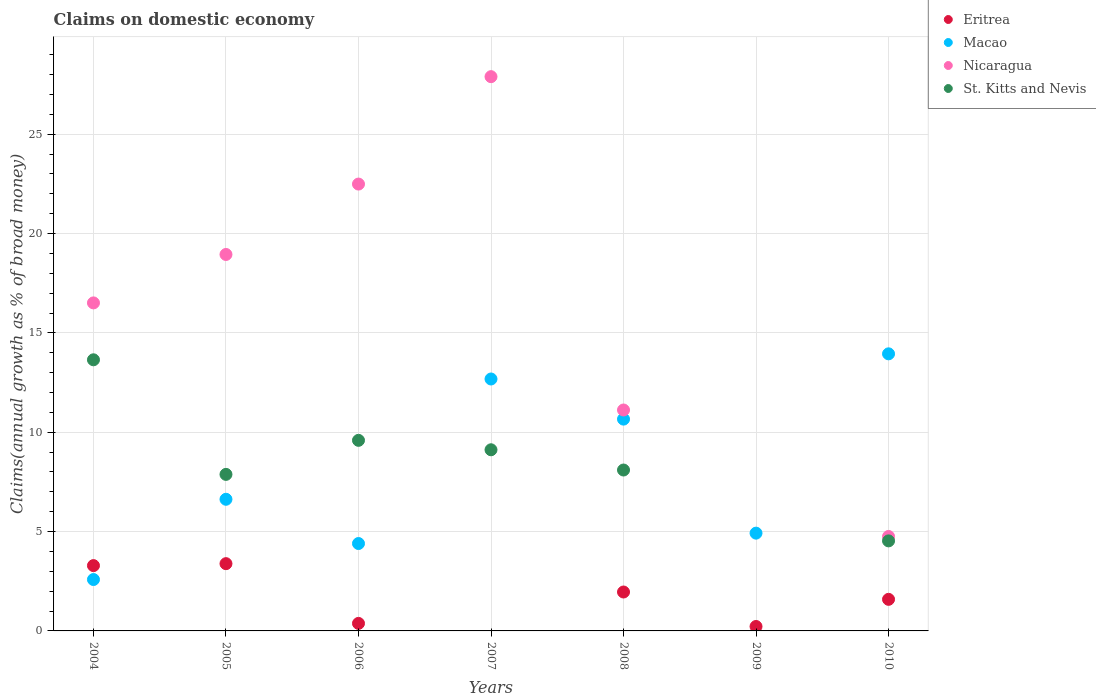How many different coloured dotlines are there?
Your response must be concise. 4. What is the percentage of broad money claimed on domestic economy in Eritrea in 2010?
Keep it short and to the point. 1.59. Across all years, what is the maximum percentage of broad money claimed on domestic economy in Nicaragua?
Give a very brief answer. 27.9. Across all years, what is the minimum percentage of broad money claimed on domestic economy in Macao?
Offer a terse response. 2.59. In which year was the percentage of broad money claimed on domestic economy in St. Kitts and Nevis maximum?
Your response must be concise. 2004. What is the total percentage of broad money claimed on domestic economy in Macao in the graph?
Provide a short and direct response. 55.82. What is the difference between the percentage of broad money claimed on domestic economy in St. Kitts and Nevis in 2004 and that in 2006?
Offer a terse response. 4.05. What is the difference between the percentage of broad money claimed on domestic economy in Nicaragua in 2009 and the percentage of broad money claimed on domestic economy in Macao in 2007?
Your answer should be compact. -12.68. What is the average percentage of broad money claimed on domestic economy in Nicaragua per year?
Provide a short and direct response. 14.53. In the year 2007, what is the difference between the percentage of broad money claimed on domestic economy in St. Kitts and Nevis and percentage of broad money claimed on domestic economy in Nicaragua?
Offer a very short reply. -18.78. What is the ratio of the percentage of broad money claimed on domestic economy in Nicaragua in 2006 to that in 2008?
Your answer should be very brief. 2.02. Is the percentage of broad money claimed on domestic economy in Nicaragua in 2005 less than that in 2008?
Provide a short and direct response. No. What is the difference between the highest and the second highest percentage of broad money claimed on domestic economy in Macao?
Offer a terse response. 1.27. What is the difference between the highest and the lowest percentage of broad money claimed on domestic economy in St. Kitts and Nevis?
Provide a succinct answer. 13.65. In how many years, is the percentage of broad money claimed on domestic economy in Nicaragua greater than the average percentage of broad money claimed on domestic economy in Nicaragua taken over all years?
Your answer should be very brief. 4. Is it the case that in every year, the sum of the percentage of broad money claimed on domestic economy in Eritrea and percentage of broad money claimed on domestic economy in Macao  is greater than the percentage of broad money claimed on domestic economy in St. Kitts and Nevis?
Provide a short and direct response. No. Is the percentage of broad money claimed on domestic economy in Nicaragua strictly greater than the percentage of broad money claimed on domestic economy in St. Kitts and Nevis over the years?
Provide a short and direct response. Yes. Is the percentage of broad money claimed on domestic economy in St. Kitts and Nevis strictly less than the percentage of broad money claimed on domestic economy in Macao over the years?
Provide a succinct answer. No. Are the values on the major ticks of Y-axis written in scientific E-notation?
Offer a very short reply. No. Does the graph contain any zero values?
Provide a short and direct response. Yes. Does the graph contain grids?
Make the answer very short. Yes. Where does the legend appear in the graph?
Ensure brevity in your answer.  Top right. What is the title of the graph?
Keep it short and to the point. Claims on domestic economy. What is the label or title of the Y-axis?
Provide a succinct answer. Claims(annual growth as % of broad money). What is the Claims(annual growth as % of broad money) in Eritrea in 2004?
Ensure brevity in your answer.  3.29. What is the Claims(annual growth as % of broad money) of Macao in 2004?
Your answer should be compact. 2.59. What is the Claims(annual growth as % of broad money) of Nicaragua in 2004?
Ensure brevity in your answer.  16.51. What is the Claims(annual growth as % of broad money) of St. Kitts and Nevis in 2004?
Keep it short and to the point. 13.65. What is the Claims(annual growth as % of broad money) of Eritrea in 2005?
Ensure brevity in your answer.  3.39. What is the Claims(annual growth as % of broad money) of Macao in 2005?
Your answer should be compact. 6.63. What is the Claims(annual growth as % of broad money) in Nicaragua in 2005?
Provide a short and direct response. 18.95. What is the Claims(annual growth as % of broad money) in St. Kitts and Nevis in 2005?
Keep it short and to the point. 7.88. What is the Claims(annual growth as % of broad money) in Eritrea in 2006?
Offer a terse response. 0.38. What is the Claims(annual growth as % of broad money) in Macao in 2006?
Provide a succinct answer. 4.4. What is the Claims(annual growth as % of broad money) in Nicaragua in 2006?
Offer a terse response. 22.49. What is the Claims(annual growth as % of broad money) in St. Kitts and Nevis in 2006?
Provide a short and direct response. 9.59. What is the Claims(annual growth as % of broad money) in Macao in 2007?
Your answer should be compact. 12.68. What is the Claims(annual growth as % of broad money) in Nicaragua in 2007?
Make the answer very short. 27.9. What is the Claims(annual growth as % of broad money) in St. Kitts and Nevis in 2007?
Offer a very short reply. 9.12. What is the Claims(annual growth as % of broad money) of Eritrea in 2008?
Offer a terse response. 1.96. What is the Claims(annual growth as % of broad money) of Macao in 2008?
Give a very brief answer. 10.66. What is the Claims(annual growth as % of broad money) in Nicaragua in 2008?
Your answer should be very brief. 11.12. What is the Claims(annual growth as % of broad money) in St. Kitts and Nevis in 2008?
Offer a very short reply. 8.1. What is the Claims(annual growth as % of broad money) of Eritrea in 2009?
Offer a very short reply. 0.22. What is the Claims(annual growth as % of broad money) of Macao in 2009?
Your answer should be very brief. 4.92. What is the Claims(annual growth as % of broad money) of Nicaragua in 2009?
Offer a terse response. 0. What is the Claims(annual growth as % of broad money) of Eritrea in 2010?
Keep it short and to the point. 1.59. What is the Claims(annual growth as % of broad money) in Macao in 2010?
Offer a very short reply. 13.95. What is the Claims(annual growth as % of broad money) of Nicaragua in 2010?
Provide a short and direct response. 4.75. What is the Claims(annual growth as % of broad money) of St. Kitts and Nevis in 2010?
Make the answer very short. 4.53. Across all years, what is the maximum Claims(annual growth as % of broad money) in Eritrea?
Keep it short and to the point. 3.39. Across all years, what is the maximum Claims(annual growth as % of broad money) of Macao?
Your answer should be very brief. 13.95. Across all years, what is the maximum Claims(annual growth as % of broad money) of Nicaragua?
Offer a terse response. 27.9. Across all years, what is the maximum Claims(annual growth as % of broad money) of St. Kitts and Nevis?
Your answer should be compact. 13.65. Across all years, what is the minimum Claims(annual growth as % of broad money) in Eritrea?
Your answer should be very brief. 0. Across all years, what is the minimum Claims(annual growth as % of broad money) in Macao?
Make the answer very short. 2.59. Across all years, what is the minimum Claims(annual growth as % of broad money) of Nicaragua?
Make the answer very short. 0. What is the total Claims(annual growth as % of broad money) in Eritrea in the graph?
Provide a succinct answer. 10.82. What is the total Claims(annual growth as % of broad money) of Macao in the graph?
Keep it short and to the point. 55.82. What is the total Claims(annual growth as % of broad money) in Nicaragua in the graph?
Your answer should be compact. 101.71. What is the total Claims(annual growth as % of broad money) of St. Kitts and Nevis in the graph?
Keep it short and to the point. 52.86. What is the difference between the Claims(annual growth as % of broad money) in Eritrea in 2004 and that in 2005?
Offer a terse response. -0.1. What is the difference between the Claims(annual growth as % of broad money) of Macao in 2004 and that in 2005?
Make the answer very short. -4.04. What is the difference between the Claims(annual growth as % of broad money) in Nicaragua in 2004 and that in 2005?
Provide a short and direct response. -2.44. What is the difference between the Claims(annual growth as % of broad money) in St. Kitts and Nevis in 2004 and that in 2005?
Offer a very short reply. 5.77. What is the difference between the Claims(annual growth as % of broad money) of Eritrea in 2004 and that in 2006?
Make the answer very short. 2.91. What is the difference between the Claims(annual growth as % of broad money) of Macao in 2004 and that in 2006?
Provide a short and direct response. -1.81. What is the difference between the Claims(annual growth as % of broad money) of Nicaragua in 2004 and that in 2006?
Provide a succinct answer. -5.98. What is the difference between the Claims(annual growth as % of broad money) in St. Kitts and Nevis in 2004 and that in 2006?
Your answer should be very brief. 4.05. What is the difference between the Claims(annual growth as % of broad money) in Macao in 2004 and that in 2007?
Your response must be concise. -10.09. What is the difference between the Claims(annual growth as % of broad money) of Nicaragua in 2004 and that in 2007?
Give a very brief answer. -11.39. What is the difference between the Claims(annual growth as % of broad money) in St. Kitts and Nevis in 2004 and that in 2007?
Your response must be concise. 4.53. What is the difference between the Claims(annual growth as % of broad money) of Eritrea in 2004 and that in 2008?
Provide a succinct answer. 1.33. What is the difference between the Claims(annual growth as % of broad money) of Macao in 2004 and that in 2008?
Provide a succinct answer. -8.07. What is the difference between the Claims(annual growth as % of broad money) of Nicaragua in 2004 and that in 2008?
Provide a short and direct response. 5.39. What is the difference between the Claims(annual growth as % of broad money) of St. Kitts and Nevis in 2004 and that in 2008?
Ensure brevity in your answer.  5.55. What is the difference between the Claims(annual growth as % of broad money) of Eritrea in 2004 and that in 2009?
Provide a succinct answer. 3.06. What is the difference between the Claims(annual growth as % of broad money) in Macao in 2004 and that in 2009?
Your response must be concise. -2.33. What is the difference between the Claims(annual growth as % of broad money) of Eritrea in 2004 and that in 2010?
Offer a terse response. 1.7. What is the difference between the Claims(annual growth as % of broad money) of Macao in 2004 and that in 2010?
Offer a very short reply. -11.36. What is the difference between the Claims(annual growth as % of broad money) in Nicaragua in 2004 and that in 2010?
Provide a short and direct response. 11.76. What is the difference between the Claims(annual growth as % of broad money) of St. Kitts and Nevis in 2004 and that in 2010?
Provide a short and direct response. 9.11. What is the difference between the Claims(annual growth as % of broad money) in Eritrea in 2005 and that in 2006?
Make the answer very short. 3.01. What is the difference between the Claims(annual growth as % of broad money) of Macao in 2005 and that in 2006?
Your response must be concise. 2.23. What is the difference between the Claims(annual growth as % of broad money) of Nicaragua in 2005 and that in 2006?
Provide a succinct answer. -3.54. What is the difference between the Claims(annual growth as % of broad money) of St. Kitts and Nevis in 2005 and that in 2006?
Ensure brevity in your answer.  -1.71. What is the difference between the Claims(annual growth as % of broad money) of Macao in 2005 and that in 2007?
Offer a very short reply. -6.05. What is the difference between the Claims(annual growth as % of broad money) of Nicaragua in 2005 and that in 2007?
Offer a very short reply. -8.95. What is the difference between the Claims(annual growth as % of broad money) in St. Kitts and Nevis in 2005 and that in 2007?
Your response must be concise. -1.24. What is the difference between the Claims(annual growth as % of broad money) in Eritrea in 2005 and that in 2008?
Give a very brief answer. 1.43. What is the difference between the Claims(annual growth as % of broad money) in Macao in 2005 and that in 2008?
Your answer should be compact. -4.03. What is the difference between the Claims(annual growth as % of broad money) of Nicaragua in 2005 and that in 2008?
Provide a short and direct response. 7.83. What is the difference between the Claims(annual growth as % of broad money) in St. Kitts and Nevis in 2005 and that in 2008?
Ensure brevity in your answer.  -0.22. What is the difference between the Claims(annual growth as % of broad money) in Eritrea in 2005 and that in 2009?
Offer a terse response. 3.16. What is the difference between the Claims(annual growth as % of broad money) in Macao in 2005 and that in 2009?
Offer a terse response. 1.7. What is the difference between the Claims(annual growth as % of broad money) in Eritrea in 2005 and that in 2010?
Your answer should be compact. 1.8. What is the difference between the Claims(annual growth as % of broad money) in Macao in 2005 and that in 2010?
Offer a terse response. -7.32. What is the difference between the Claims(annual growth as % of broad money) in Nicaragua in 2005 and that in 2010?
Provide a short and direct response. 14.19. What is the difference between the Claims(annual growth as % of broad money) of St. Kitts and Nevis in 2005 and that in 2010?
Offer a very short reply. 3.35. What is the difference between the Claims(annual growth as % of broad money) in Macao in 2006 and that in 2007?
Provide a succinct answer. -8.28. What is the difference between the Claims(annual growth as % of broad money) in Nicaragua in 2006 and that in 2007?
Offer a very short reply. -5.41. What is the difference between the Claims(annual growth as % of broad money) of St. Kitts and Nevis in 2006 and that in 2007?
Make the answer very short. 0.47. What is the difference between the Claims(annual growth as % of broad money) of Eritrea in 2006 and that in 2008?
Your answer should be very brief. -1.58. What is the difference between the Claims(annual growth as % of broad money) of Macao in 2006 and that in 2008?
Offer a terse response. -6.26. What is the difference between the Claims(annual growth as % of broad money) of Nicaragua in 2006 and that in 2008?
Keep it short and to the point. 11.37. What is the difference between the Claims(annual growth as % of broad money) in St. Kitts and Nevis in 2006 and that in 2008?
Ensure brevity in your answer.  1.49. What is the difference between the Claims(annual growth as % of broad money) in Eritrea in 2006 and that in 2009?
Give a very brief answer. 0.16. What is the difference between the Claims(annual growth as % of broad money) of Macao in 2006 and that in 2009?
Your answer should be very brief. -0.52. What is the difference between the Claims(annual growth as % of broad money) in Eritrea in 2006 and that in 2010?
Offer a terse response. -1.21. What is the difference between the Claims(annual growth as % of broad money) in Macao in 2006 and that in 2010?
Provide a short and direct response. -9.55. What is the difference between the Claims(annual growth as % of broad money) in Nicaragua in 2006 and that in 2010?
Offer a terse response. 17.74. What is the difference between the Claims(annual growth as % of broad money) of St. Kitts and Nevis in 2006 and that in 2010?
Keep it short and to the point. 5.06. What is the difference between the Claims(annual growth as % of broad money) of Macao in 2007 and that in 2008?
Give a very brief answer. 2.02. What is the difference between the Claims(annual growth as % of broad money) in Nicaragua in 2007 and that in 2008?
Your response must be concise. 16.78. What is the difference between the Claims(annual growth as % of broad money) of St. Kitts and Nevis in 2007 and that in 2008?
Provide a short and direct response. 1.02. What is the difference between the Claims(annual growth as % of broad money) of Macao in 2007 and that in 2009?
Give a very brief answer. 7.76. What is the difference between the Claims(annual growth as % of broad money) of Macao in 2007 and that in 2010?
Provide a succinct answer. -1.27. What is the difference between the Claims(annual growth as % of broad money) in Nicaragua in 2007 and that in 2010?
Offer a terse response. 23.14. What is the difference between the Claims(annual growth as % of broad money) in St. Kitts and Nevis in 2007 and that in 2010?
Offer a very short reply. 4.59. What is the difference between the Claims(annual growth as % of broad money) in Eritrea in 2008 and that in 2009?
Offer a very short reply. 1.74. What is the difference between the Claims(annual growth as % of broad money) of Macao in 2008 and that in 2009?
Make the answer very short. 5.74. What is the difference between the Claims(annual growth as % of broad money) in Eritrea in 2008 and that in 2010?
Provide a short and direct response. 0.37. What is the difference between the Claims(annual growth as % of broad money) in Macao in 2008 and that in 2010?
Offer a very short reply. -3.29. What is the difference between the Claims(annual growth as % of broad money) of Nicaragua in 2008 and that in 2010?
Your answer should be very brief. 6.37. What is the difference between the Claims(annual growth as % of broad money) of St. Kitts and Nevis in 2008 and that in 2010?
Your answer should be compact. 3.57. What is the difference between the Claims(annual growth as % of broad money) of Eritrea in 2009 and that in 2010?
Your answer should be compact. -1.37. What is the difference between the Claims(annual growth as % of broad money) in Macao in 2009 and that in 2010?
Ensure brevity in your answer.  -9.02. What is the difference between the Claims(annual growth as % of broad money) of Eritrea in 2004 and the Claims(annual growth as % of broad money) of Macao in 2005?
Provide a short and direct response. -3.34. What is the difference between the Claims(annual growth as % of broad money) of Eritrea in 2004 and the Claims(annual growth as % of broad money) of Nicaragua in 2005?
Offer a very short reply. -15.66. What is the difference between the Claims(annual growth as % of broad money) of Eritrea in 2004 and the Claims(annual growth as % of broad money) of St. Kitts and Nevis in 2005?
Your answer should be compact. -4.59. What is the difference between the Claims(annual growth as % of broad money) in Macao in 2004 and the Claims(annual growth as % of broad money) in Nicaragua in 2005?
Your response must be concise. -16.36. What is the difference between the Claims(annual growth as % of broad money) of Macao in 2004 and the Claims(annual growth as % of broad money) of St. Kitts and Nevis in 2005?
Your response must be concise. -5.29. What is the difference between the Claims(annual growth as % of broad money) of Nicaragua in 2004 and the Claims(annual growth as % of broad money) of St. Kitts and Nevis in 2005?
Offer a terse response. 8.63. What is the difference between the Claims(annual growth as % of broad money) of Eritrea in 2004 and the Claims(annual growth as % of broad money) of Macao in 2006?
Keep it short and to the point. -1.11. What is the difference between the Claims(annual growth as % of broad money) in Eritrea in 2004 and the Claims(annual growth as % of broad money) in Nicaragua in 2006?
Your answer should be very brief. -19.2. What is the difference between the Claims(annual growth as % of broad money) in Eritrea in 2004 and the Claims(annual growth as % of broad money) in St. Kitts and Nevis in 2006?
Your answer should be compact. -6.3. What is the difference between the Claims(annual growth as % of broad money) of Macao in 2004 and the Claims(annual growth as % of broad money) of Nicaragua in 2006?
Keep it short and to the point. -19.9. What is the difference between the Claims(annual growth as % of broad money) of Macao in 2004 and the Claims(annual growth as % of broad money) of St. Kitts and Nevis in 2006?
Make the answer very short. -7.01. What is the difference between the Claims(annual growth as % of broad money) in Nicaragua in 2004 and the Claims(annual growth as % of broad money) in St. Kitts and Nevis in 2006?
Offer a very short reply. 6.92. What is the difference between the Claims(annual growth as % of broad money) in Eritrea in 2004 and the Claims(annual growth as % of broad money) in Macao in 2007?
Provide a succinct answer. -9.39. What is the difference between the Claims(annual growth as % of broad money) in Eritrea in 2004 and the Claims(annual growth as % of broad money) in Nicaragua in 2007?
Provide a succinct answer. -24.61. What is the difference between the Claims(annual growth as % of broad money) in Eritrea in 2004 and the Claims(annual growth as % of broad money) in St. Kitts and Nevis in 2007?
Offer a terse response. -5.83. What is the difference between the Claims(annual growth as % of broad money) of Macao in 2004 and the Claims(annual growth as % of broad money) of Nicaragua in 2007?
Make the answer very short. -25.31. What is the difference between the Claims(annual growth as % of broad money) in Macao in 2004 and the Claims(annual growth as % of broad money) in St. Kitts and Nevis in 2007?
Offer a terse response. -6.53. What is the difference between the Claims(annual growth as % of broad money) of Nicaragua in 2004 and the Claims(annual growth as % of broad money) of St. Kitts and Nevis in 2007?
Provide a short and direct response. 7.39. What is the difference between the Claims(annual growth as % of broad money) of Eritrea in 2004 and the Claims(annual growth as % of broad money) of Macao in 2008?
Keep it short and to the point. -7.37. What is the difference between the Claims(annual growth as % of broad money) of Eritrea in 2004 and the Claims(annual growth as % of broad money) of Nicaragua in 2008?
Give a very brief answer. -7.83. What is the difference between the Claims(annual growth as % of broad money) of Eritrea in 2004 and the Claims(annual growth as % of broad money) of St. Kitts and Nevis in 2008?
Offer a terse response. -4.81. What is the difference between the Claims(annual growth as % of broad money) in Macao in 2004 and the Claims(annual growth as % of broad money) in Nicaragua in 2008?
Make the answer very short. -8.53. What is the difference between the Claims(annual growth as % of broad money) in Macao in 2004 and the Claims(annual growth as % of broad money) in St. Kitts and Nevis in 2008?
Provide a succinct answer. -5.51. What is the difference between the Claims(annual growth as % of broad money) of Nicaragua in 2004 and the Claims(annual growth as % of broad money) of St. Kitts and Nevis in 2008?
Make the answer very short. 8.41. What is the difference between the Claims(annual growth as % of broad money) of Eritrea in 2004 and the Claims(annual growth as % of broad money) of Macao in 2009?
Make the answer very short. -1.63. What is the difference between the Claims(annual growth as % of broad money) in Eritrea in 2004 and the Claims(annual growth as % of broad money) in Macao in 2010?
Your answer should be very brief. -10.66. What is the difference between the Claims(annual growth as % of broad money) in Eritrea in 2004 and the Claims(annual growth as % of broad money) in Nicaragua in 2010?
Provide a short and direct response. -1.47. What is the difference between the Claims(annual growth as % of broad money) of Eritrea in 2004 and the Claims(annual growth as % of broad money) of St. Kitts and Nevis in 2010?
Your response must be concise. -1.24. What is the difference between the Claims(annual growth as % of broad money) in Macao in 2004 and the Claims(annual growth as % of broad money) in Nicaragua in 2010?
Offer a terse response. -2.17. What is the difference between the Claims(annual growth as % of broad money) of Macao in 2004 and the Claims(annual growth as % of broad money) of St. Kitts and Nevis in 2010?
Keep it short and to the point. -1.95. What is the difference between the Claims(annual growth as % of broad money) in Nicaragua in 2004 and the Claims(annual growth as % of broad money) in St. Kitts and Nevis in 2010?
Ensure brevity in your answer.  11.98. What is the difference between the Claims(annual growth as % of broad money) of Eritrea in 2005 and the Claims(annual growth as % of broad money) of Macao in 2006?
Offer a very short reply. -1.01. What is the difference between the Claims(annual growth as % of broad money) of Eritrea in 2005 and the Claims(annual growth as % of broad money) of Nicaragua in 2006?
Offer a very short reply. -19.1. What is the difference between the Claims(annual growth as % of broad money) of Eritrea in 2005 and the Claims(annual growth as % of broad money) of St. Kitts and Nevis in 2006?
Provide a short and direct response. -6.21. What is the difference between the Claims(annual growth as % of broad money) in Macao in 2005 and the Claims(annual growth as % of broad money) in Nicaragua in 2006?
Offer a very short reply. -15.86. What is the difference between the Claims(annual growth as % of broad money) of Macao in 2005 and the Claims(annual growth as % of broad money) of St. Kitts and Nevis in 2006?
Your response must be concise. -2.97. What is the difference between the Claims(annual growth as % of broad money) in Nicaragua in 2005 and the Claims(annual growth as % of broad money) in St. Kitts and Nevis in 2006?
Offer a very short reply. 9.35. What is the difference between the Claims(annual growth as % of broad money) in Eritrea in 2005 and the Claims(annual growth as % of broad money) in Macao in 2007?
Your answer should be very brief. -9.29. What is the difference between the Claims(annual growth as % of broad money) of Eritrea in 2005 and the Claims(annual growth as % of broad money) of Nicaragua in 2007?
Your answer should be compact. -24.51. What is the difference between the Claims(annual growth as % of broad money) of Eritrea in 2005 and the Claims(annual growth as % of broad money) of St. Kitts and Nevis in 2007?
Offer a terse response. -5.73. What is the difference between the Claims(annual growth as % of broad money) in Macao in 2005 and the Claims(annual growth as % of broad money) in Nicaragua in 2007?
Your answer should be compact. -21.27. What is the difference between the Claims(annual growth as % of broad money) of Macao in 2005 and the Claims(annual growth as % of broad money) of St. Kitts and Nevis in 2007?
Your answer should be compact. -2.49. What is the difference between the Claims(annual growth as % of broad money) of Nicaragua in 2005 and the Claims(annual growth as % of broad money) of St. Kitts and Nevis in 2007?
Give a very brief answer. 9.83. What is the difference between the Claims(annual growth as % of broad money) in Eritrea in 2005 and the Claims(annual growth as % of broad money) in Macao in 2008?
Your answer should be compact. -7.27. What is the difference between the Claims(annual growth as % of broad money) in Eritrea in 2005 and the Claims(annual growth as % of broad money) in Nicaragua in 2008?
Keep it short and to the point. -7.73. What is the difference between the Claims(annual growth as % of broad money) of Eritrea in 2005 and the Claims(annual growth as % of broad money) of St. Kitts and Nevis in 2008?
Give a very brief answer. -4.71. What is the difference between the Claims(annual growth as % of broad money) in Macao in 2005 and the Claims(annual growth as % of broad money) in Nicaragua in 2008?
Ensure brevity in your answer.  -4.49. What is the difference between the Claims(annual growth as % of broad money) in Macao in 2005 and the Claims(annual growth as % of broad money) in St. Kitts and Nevis in 2008?
Give a very brief answer. -1.47. What is the difference between the Claims(annual growth as % of broad money) in Nicaragua in 2005 and the Claims(annual growth as % of broad money) in St. Kitts and Nevis in 2008?
Keep it short and to the point. 10.85. What is the difference between the Claims(annual growth as % of broad money) of Eritrea in 2005 and the Claims(annual growth as % of broad money) of Macao in 2009?
Your answer should be compact. -1.54. What is the difference between the Claims(annual growth as % of broad money) of Eritrea in 2005 and the Claims(annual growth as % of broad money) of Macao in 2010?
Your answer should be compact. -10.56. What is the difference between the Claims(annual growth as % of broad money) of Eritrea in 2005 and the Claims(annual growth as % of broad money) of Nicaragua in 2010?
Your answer should be compact. -1.37. What is the difference between the Claims(annual growth as % of broad money) of Eritrea in 2005 and the Claims(annual growth as % of broad money) of St. Kitts and Nevis in 2010?
Your answer should be compact. -1.15. What is the difference between the Claims(annual growth as % of broad money) of Macao in 2005 and the Claims(annual growth as % of broad money) of Nicaragua in 2010?
Provide a succinct answer. 1.87. What is the difference between the Claims(annual growth as % of broad money) in Macao in 2005 and the Claims(annual growth as % of broad money) in St. Kitts and Nevis in 2010?
Ensure brevity in your answer.  2.09. What is the difference between the Claims(annual growth as % of broad money) in Nicaragua in 2005 and the Claims(annual growth as % of broad money) in St. Kitts and Nevis in 2010?
Your answer should be very brief. 14.41. What is the difference between the Claims(annual growth as % of broad money) in Eritrea in 2006 and the Claims(annual growth as % of broad money) in Macao in 2007?
Provide a short and direct response. -12.3. What is the difference between the Claims(annual growth as % of broad money) in Eritrea in 2006 and the Claims(annual growth as % of broad money) in Nicaragua in 2007?
Your answer should be compact. -27.52. What is the difference between the Claims(annual growth as % of broad money) in Eritrea in 2006 and the Claims(annual growth as % of broad money) in St. Kitts and Nevis in 2007?
Give a very brief answer. -8.74. What is the difference between the Claims(annual growth as % of broad money) of Macao in 2006 and the Claims(annual growth as % of broad money) of Nicaragua in 2007?
Offer a terse response. -23.5. What is the difference between the Claims(annual growth as % of broad money) in Macao in 2006 and the Claims(annual growth as % of broad money) in St. Kitts and Nevis in 2007?
Make the answer very short. -4.72. What is the difference between the Claims(annual growth as % of broad money) in Nicaragua in 2006 and the Claims(annual growth as % of broad money) in St. Kitts and Nevis in 2007?
Provide a succinct answer. 13.37. What is the difference between the Claims(annual growth as % of broad money) of Eritrea in 2006 and the Claims(annual growth as % of broad money) of Macao in 2008?
Give a very brief answer. -10.28. What is the difference between the Claims(annual growth as % of broad money) of Eritrea in 2006 and the Claims(annual growth as % of broad money) of Nicaragua in 2008?
Give a very brief answer. -10.74. What is the difference between the Claims(annual growth as % of broad money) of Eritrea in 2006 and the Claims(annual growth as % of broad money) of St. Kitts and Nevis in 2008?
Keep it short and to the point. -7.72. What is the difference between the Claims(annual growth as % of broad money) in Macao in 2006 and the Claims(annual growth as % of broad money) in Nicaragua in 2008?
Offer a very short reply. -6.72. What is the difference between the Claims(annual growth as % of broad money) in Macao in 2006 and the Claims(annual growth as % of broad money) in St. Kitts and Nevis in 2008?
Provide a succinct answer. -3.7. What is the difference between the Claims(annual growth as % of broad money) of Nicaragua in 2006 and the Claims(annual growth as % of broad money) of St. Kitts and Nevis in 2008?
Offer a very short reply. 14.39. What is the difference between the Claims(annual growth as % of broad money) of Eritrea in 2006 and the Claims(annual growth as % of broad money) of Macao in 2009?
Offer a very short reply. -4.54. What is the difference between the Claims(annual growth as % of broad money) in Eritrea in 2006 and the Claims(annual growth as % of broad money) in Macao in 2010?
Your answer should be very brief. -13.57. What is the difference between the Claims(annual growth as % of broad money) in Eritrea in 2006 and the Claims(annual growth as % of broad money) in Nicaragua in 2010?
Give a very brief answer. -4.37. What is the difference between the Claims(annual growth as % of broad money) in Eritrea in 2006 and the Claims(annual growth as % of broad money) in St. Kitts and Nevis in 2010?
Your answer should be very brief. -4.15. What is the difference between the Claims(annual growth as % of broad money) in Macao in 2006 and the Claims(annual growth as % of broad money) in Nicaragua in 2010?
Keep it short and to the point. -0.36. What is the difference between the Claims(annual growth as % of broad money) in Macao in 2006 and the Claims(annual growth as % of broad money) in St. Kitts and Nevis in 2010?
Your response must be concise. -0.13. What is the difference between the Claims(annual growth as % of broad money) of Nicaragua in 2006 and the Claims(annual growth as % of broad money) of St. Kitts and Nevis in 2010?
Offer a terse response. 17.96. What is the difference between the Claims(annual growth as % of broad money) of Macao in 2007 and the Claims(annual growth as % of broad money) of Nicaragua in 2008?
Your answer should be very brief. 1.56. What is the difference between the Claims(annual growth as % of broad money) of Macao in 2007 and the Claims(annual growth as % of broad money) of St. Kitts and Nevis in 2008?
Ensure brevity in your answer.  4.58. What is the difference between the Claims(annual growth as % of broad money) in Nicaragua in 2007 and the Claims(annual growth as % of broad money) in St. Kitts and Nevis in 2008?
Make the answer very short. 19.8. What is the difference between the Claims(annual growth as % of broad money) of Macao in 2007 and the Claims(annual growth as % of broad money) of Nicaragua in 2010?
Ensure brevity in your answer.  7.93. What is the difference between the Claims(annual growth as % of broad money) in Macao in 2007 and the Claims(annual growth as % of broad money) in St. Kitts and Nevis in 2010?
Provide a succinct answer. 8.15. What is the difference between the Claims(annual growth as % of broad money) of Nicaragua in 2007 and the Claims(annual growth as % of broad money) of St. Kitts and Nevis in 2010?
Your answer should be very brief. 23.36. What is the difference between the Claims(annual growth as % of broad money) of Eritrea in 2008 and the Claims(annual growth as % of broad money) of Macao in 2009?
Your answer should be very brief. -2.96. What is the difference between the Claims(annual growth as % of broad money) in Eritrea in 2008 and the Claims(annual growth as % of broad money) in Macao in 2010?
Provide a short and direct response. -11.99. What is the difference between the Claims(annual growth as % of broad money) of Eritrea in 2008 and the Claims(annual growth as % of broad money) of Nicaragua in 2010?
Make the answer very short. -2.8. What is the difference between the Claims(annual growth as % of broad money) in Eritrea in 2008 and the Claims(annual growth as % of broad money) in St. Kitts and Nevis in 2010?
Your answer should be compact. -2.57. What is the difference between the Claims(annual growth as % of broad money) in Macao in 2008 and the Claims(annual growth as % of broad money) in Nicaragua in 2010?
Make the answer very short. 5.91. What is the difference between the Claims(annual growth as % of broad money) in Macao in 2008 and the Claims(annual growth as % of broad money) in St. Kitts and Nevis in 2010?
Your answer should be very brief. 6.13. What is the difference between the Claims(annual growth as % of broad money) in Nicaragua in 2008 and the Claims(annual growth as % of broad money) in St. Kitts and Nevis in 2010?
Your response must be concise. 6.59. What is the difference between the Claims(annual growth as % of broad money) of Eritrea in 2009 and the Claims(annual growth as % of broad money) of Macao in 2010?
Ensure brevity in your answer.  -13.72. What is the difference between the Claims(annual growth as % of broad money) in Eritrea in 2009 and the Claims(annual growth as % of broad money) in Nicaragua in 2010?
Provide a short and direct response. -4.53. What is the difference between the Claims(annual growth as % of broad money) of Eritrea in 2009 and the Claims(annual growth as % of broad money) of St. Kitts and Nevis in 2010?
Your response must be concise. -4.31. What is the difference between the Claims(annual growth as % of broad money) in Macao in 2009 and the Claims(annual growth as % of broad money) in Nicaragua in 2010?
Your answer should be compact. 0.17. What is the difference between the Claims(annual growth as % of broad money) of Macao in 2009 and the Claims(annual growth as % of broad money) of St. Kitts and Nevis in 2010?
Offer a very short reply. 0.39. What is the average Claims(annual growth as % of broad money) in Eritrea per year?
Keep it short and to the point. 1.55. What is the average Claims(annual growth as % of broad money) in Macao per year?
Provide a succinct answer. 7.97. What is the average Claims(annual growth as % of broad money) in Nicaragua per year?
Give a very brief answer. 14.53. What is the average Claims(annual growth as % of broad money) in St. Kitts and Nevis per year?
Ensure brevity in your answer.  7.55. In the year 2004, what is the difference between the Claims(annual growth as % of broad money) of Eritrea and Claims(annual growth as % of broad money) of Macao?
Your response must be concise. 0.7. In the year 2004, what is the difference between the Claims(annual growth as % of broad money) of Eritrea and Claims(annual growth as % of broad money) of Nicaragua?
Provide a succinct answer. -13.22. In the year 2004, what is the difference between the Claims(annual growth as % of broad money) in Eritrea and Claims(annual growth as % of broad money) in St. Kitts and Nevis?
Offer a very short reply. -10.36. In the year 2004, what is the difference between the Claims(annual growth as % of broad money) of Macao and Claims(annual growth as % of broad money) of Nicaragua?
Your answer should be very brief. -13.92. In the year 2004, what is the difference between the Claims(annual growth as % of broad money) in Macao and Claims(annual growth as % of broad money) in St. Kitts and Nevis?
Your response must be concise. -11.06. In the year 2004, what is the difference between the Claims(annual growth as % of broad money) of Nicaragua and Claims(annual growth as % of broad money) of St. Kitts and Nevis?
Offer a terse response. 2.86. In the year 2005, what is the difference between the Claims(annual growth as % of broad money) in Eritrea and Claims(annual growth as % of broad money) in Macao?
Provide a short and direct response. -3.24. In the year 2005, what is the difference between the Claims(annual growth as % of broad money) of Eritrea and Claims(annual growth as % of broad money) of Nicaragua?
Offer a very short reply. -15.56. In the year 2005, what is the difference between the Claims(annual growth as % of broad money) of Eritrea and Claims(annual growth as % of broad money) of St. Kitts and Nevis?
Give a very brief answer. -4.49. In the year 2005, what is the difference between the Claims(annual growth as % of broad money) of Macao and Claims(annual growth as % of broad money) of Nicaragua?
Offer a terse response. -12.32. In the year 2005, what is the difference between the Claims(annual growth as % of broad money) of Macao and Claims(annual growth as % of broad money) of St. Kitts and Nevis?
Your answer should be compact. -1.25. In the year 2005, what is the difference between the Claims(annual growth as % of broad money) of Nicaragua and Claims(annual growth as % of broad money) of St. Kitts and Nevis?
Your response must be concise. 11.07. In the year 2006, what is the difference between the Claims(annual growth as % of broad money) in Eritrea and Claims(annual growth as % of broad money) in Macao?
Provide a succinct answer. -4.02. In the year 2006, what is the difference between the Claims(annual growth as % of broad money) of Eritrea and Claims(annual growth as % of broad money) of Nicaragua?
Your answer should be compact. -22.11. In the year 2006, what is the difference between the Claims(annual growth as % of broad money) of Eritrea and Claims(annual growth as % of broad money) of St. Kitts and Nevis?
Ensure brevity in your answer.  -9.21. In the year 2006, what is the difference between the Claims(annual growth as % of broad money) of Macao and Claims(annual growth as % of broad money) of Nicaragua?
Your answer should be compact. -18.09. In the year 2006, what is the difference between the Claims(annual growth as % of broad money) of Macao and Claims(annual growth as % of broad money) of St. Kitts and Nevis?
Your answer should be compact. -5.19. In the year 2006, what is the difference between the Claims(annual growth as % of broad money) of Nicaragua and Claims(annual growth as % of broad money) of St. Kitts and Nevis?
Your answer should be very brief. 12.9. In the year 2007, what is the difference between the Claims(annual growth as % of broad money) in Macao and Claims(annual growth as % of broad money) in Nicaragua?
Your answer should be compact. -15.22. In the year 2007, what is the difference between the Claims(annual growth as % of broad money) in Macao and Claims(annual growth as % of broad money) in St. Kitts and Nevis?
Provide a short and direct response. 3.56. In the year 2007, what is the difference between the Claims(annual growth as % of broad money) of Nicaragua and Claims(annual growth as % of broad money) of St. Kitts and Nevis?
Your answer should be compact. 18.78. In the year 2008, what is the difference between the Claims(annual growth as % of broad money) of Eritrea and Claims(annual growth as % of broad money) of Macao?
Ensure brevity in your answer.  -8.7. In the year 2008, what is the difference between the Claims(annual growth as % of broad money) in Eritrea and Claims(annual growth as % of broad money) in Nicaragua?
Provide a short and direct response. -9.16. In the year 2008, what is the difference between the Claims(annual growth as % of broad money) in Eritrea and Claims(annual growth as % of broad money) in St. Kitts and Nevis?
Give a very brief answer. -6.14. In the year 2008, what is the difference between the Claims(annual growth as % of broad money) in Macao and Claims(annual growth as % of broad money) in Nicaragua?
Ensure brevity in your answer.  -0.46. In the year 2008, what is the difference between the Claims(annual growth as % of broad money) of Macao and Claims(annual growth as % of broad money) of St. Kitts and Nevis?
Provide a short and direct response. 2.56. In the year 2008, what is the difference between the Claims(annual growth as % of broad money) of Nicaragua and Claims(annual growth as % of broad money) of St. Kitts and Nevis?
Provide a short and direct response. 3.02. In the year 2009, what is the difference between the Claims(annual growth as % of broad money) of Eritrea and Claims(annual growth as % of broad money) of Macao?
Ensure brevity in your answer.  -4.7. In the year 2010, what is the difference between the Claims(annual growth as % of broad money) of Eritrea and Claims(annual growth as % of broad money) of Macao?
Make the answer very short. -12.36. In the year 2010, what is the difference between the Claims(annual growth as % of broad money) in Eritrea and Claims(annual growth as % of broad money) in Nicaragua?
Provide a succinct answer. -3.16. In the year 2010, what is the difference between the Claims(annual growth as % of broad money) of Eritrea and Claims(annual growth as % of broad money) of St. Kitts and Nevis?
Offer a terse response. -2.94. In the year 2010, what is the difference between the Claims(annual growth as % of broad money) in Macao and Claims(annual growth as % of broad money) in Nicaragua?
Offer a very short reply. 9.19. In the year 2010, what is the difference between the Claims(annual growth as % of broad money) in Macao and Claims(annual growth as % of broad money) in St. Kitts and Nevis?
Your answer should be very brief. 9.41. In the year 2010, what is the difference between the Claims(annual growth as % of broad money) in Nicaragua and Claims(annual growth as % of broad money) in St. Kitts and Nevis?
Keep it short and to the point. 0.22. What is the ratio of the Claims(annual growth as % of broad money) of Macao in 2004 to that in 2005?
Provide a succinct answer. 0.39. What is the ratio of the Claims(annual growth as % of broad money) of Nicaragua in 2004 to that in 2005?
Your answer should be compact. 0.87. What is the ratio of the Claims(annual growth as % of broad money) of St. Kitts and Nevis in 2004 to that in 2005?
Offer a terse response. 1.73. What is the ratio of the Claims(annual growth as % of broad money) in Eritrea in 2004 to that in 2006?
Your answer should be compact. 8.67. What is the ratio of the Claims(annual growth as % of broad money) of Macao in 2004 to that in 2006?
Your answer should be compact. 0.59. What is the ratio of the Claims(annual growth as % of broad money) of Nicaragua in 2004 to that in 2006?
Your response must be concise. 0.73. What is the ratio of the Claims(annual growth as % of broad money) in St. Kitts and Nevis in 2004 to that in 2006?
Provide a short and direct response. 1.42. What is the ratio of the Claims(annual growth as % of broad money) of Macao in 2004 to that in 2007?
Ensure brevity in your answer.  0.2. What is the ratio of the Claims(annual growth as % of broad money) of Nicaragua in 2004 to that in 2007?
Ensure brevity in your answer.  0.59. What is the ratio of the Claims(annual growth as % of broad money) in St. Kitts and Nevis in 2004 to that in 2007?
Your answer should be compact. 1.5. What is the ratio of the Claims(annual growth as % of broad money) in Eritrea in 2004 to that in 2008?
Keep it short and to the point. 1.68. What is the ratio of the Claims(annual growth as % of broad money) in Macao in 2004 to that in 2008?
Keep it short and to the point. 0.24. What is the ratio of the Claims(annual growth as % of broad money) of Nicaragua in 2004 to that in 2008?
Your response must be concise. 1.48. What is the ratio of the Claims(annual growth as % of broad money) in St. Kitts and Nevis in 2004 to that in 2008?
Make the answer very short. 1.69. What is the ratio of the Claims(annual growth as % of broad money) of Eritrea in 2004 to that in 2009?
Your response must be concise. 14.73. What is the ratio of the Claims(annual growth as % of broad money) of Macao in 2004 to that in 2009?
Make the answer very short. 0.53. What is the ratio of the Claims(annual growth as % of broad money) in Eritrea in 2004 to that in 2010?
Provide a succinct answer. 2.07. What is the ratio of the Claims(annual growth as % of broad money) in Macao in 2004 to that in 2010?
Provide a succinct answer. 0.19. What is the ratio of the Claims(annual growth as % of broad money) in Nicaragua in 2004 to that in 2010?
Your response must be concise. 3.47. What is the ratio of the Claims(annual growth as % of broad money) of St. Kitts and Nevis in 2004 to that in 2010?
Your answer should be compact. 3.01. What is the ratio of the Claims(annual growth as % of broad money) of Eritrea in 2005 to that in 2006?
Your response must be concise. 8.93. What is the ratio of the Claims(annual growth as % of broad money) in Macao in 2005 to that in 2006?
Ensure brevity in your answer.  1.51. What is the ratio of the Claims(annual growth as % of broad money) of Nicaragua in 2005 to that in 2006?
Provide a succinct answer. 0.84. What is the ratio of the Claims(annual growth as % of broad money) of St. Kitts and Nevis in 2005 to that in 2006?
Provide a short and direct response. 0.82. What is the ratio of the Claims(annual growth as % of broad money) of Macao in 2005 to that in 2007?
Make the answer very short. 0.52. What is the ratio of the Claims(annual growth as % of broad money) in Nicaragua in 2005 to that in 2007?
Ensure brevity in your answer.  0.68. What is the ratio of the Claims(annual growth as % of broad money) in St. Kitts and Nevis in 2005 to that in 2007?
Your response must be concise. 0.86. What is the ratio of the Claims(annual growth as % of broad money) of Eritrea in 2005 to that in 2008?
Ensure brevity in your answer.  1.73. What is the ratio of the Claims(annual growth as % of broad money) of Macao in 2005 to that in 2008?
Give a very brief answer. 0.62. What is the ratio of the Claims(annual growth as % of broad money) in Nicaragua in 2005 to that in 2008?
Your answer should be compact. 1.7. What is the ratio of the Claims(annual growth as % of broad money) in St. Kitts and Nevis in 2005 to that in 2008?
Offer a very short reply. 0.97. What is the ratio of the Claims(annual growth as % of broad money) in Eritrea in 2005 to that in 2009?
Ensure brevity in your answer.  15.16. What is the ratio of the Claims(annual growth as % of broad money) of Macao in 2005 to that in 2009?
Give a very brief answer. 1.35. What is the ratio of the Claims(annual growth as % of broad money) of Eritrea in 2005 to that in 2010?
Your answer should be very brief. 2.13. What is the ratio of the Claims(annual growth as % of broad money) of Macao in 2005 to that in 2010?
Give a very brief answer. 0.48. What is the ratio of the Claims(annual growth as % of broad money) of Nicaragua in 2005 to that in 2010?
Provide a succinct answer. 3.99. What is the ratio of the Claims(annual growth as % of broad money) in St. Kitts and Nevis in 2005 to that in 2010?
Ensure brevity in your answer.  1.74. What is the ratio of the Claims(annual growth as % of broad money) of Macao in 2006 to that in 2007?
Give a very brief answer. 0.35. What is the ratio of the Claims(annual growth as % of broad money) of Nicaragua in 2006 to that in 2007?
Keep it short and to the point. 0.81. What is the ratio of the Claims(annual growth as % of broad money) in St. Kitts and Nevis in 2006 to that in 2007?
Give a very brief answer. 1.05. What is the ratio of the Claims(annual growth as % of broad money) in Eritrea in 2006 to that in 2008?
Provide a succinct answer. 0.19. What is the ratio of the Claims(annual growth as % of broad money) in Macao in 2006 to that in 2008?
Ensure brevity in your answer.  0.41. What is the ratio of the Claims(annual growth as % of broad money) of Nicaragua in 2006 to that in 2008?
Provide a short and direct response. 2.02. What is the ratio of the Claims(annual growth as % of broad money) of St. Kitts and Nevis in 2006 to that in 2008?
Give a very brief answer. 1.18. What is the ratio of the Claims(annual growth as % of broad money) in Eritrea in 2006 to that in 2009?
Provide a succinct answer. 1.7. What is the ratio of the Claims(annual growth as % of broad money) of Macao in 2006 to that in 2009?
Offer a very short reply. 0.89. What is the ratio of the Claims(annual growth as % of broad money) in Eritrea in 2006 to that in 2010?
Give a very brief answer. 0.24. What is the ratio of the Claims(annual growth as % of broad money) of Macao in 2006 to that in 2010?
Provide a succinct answer. 0.32. What is the ratio of the Claims(annual growth as % of broad money) of Nicaragua in 2006 to that in 2010?
Provide a succinct answer. 4.73. What is the ratio of the Claims(annual growth as % of broad money) of St. Kitts and Nevis in 2006 to that in 2010?
Give a very brief answer. 2.12. What is the ratio of the Claims(annual growth as % of broad money) in Macao in 2007 to that in 2008?
Offer a very short reply. 1.19. What is the ratio of the Claims(annual growth as % of broad money) in Nicaragua in 2007 to that in 2008?
Your answer should be very brief. 2.51. What is the ratio of the Claims(annual growth as % of broad money) of St. Kitts and Nevis in 2007 to that in 2008?
Ensure brevity in your answer.  1.13. What is the ratio of the Claims(annual growth as % of broad money) of Macao in 2007 to that in 2009?
Give a very brief answer. 2.58. What is the ratio of the Claims(annual growth as % of broad money) in Macao in 2007 to that in 2010?
Ensure brevity in your answer.  0.91. What is the ratio of the Claims(annual growth as % of broad money) in Nicaragua in 2007 to that in 2010?
Provide a succinct answer. 5.87. What is the ratio of the Claims(annual growth as % of broad money) of St. Kitts and Nevis in 2007 to that in 2010?
Give a very brief answer. 2.01. What is the ratio of the Claims(annual growth as % of broad money) in Eritrea in 2008 to that in 2009?
Your answer should be compact. 8.77. What is the ratio of the Claims(annual growth as % of broad money) of Macao in 2008 to that in 2009?
Make the answer very short. 2.17. What is the ratio of the Claims(annual growth as % of broad money) in Eritrea in 2008 to that in 2010?
Provide a succinct answer. 1.23. What is the ratio of the Claims(annual growth as % of broad money) in Macao in 2008 to that in 2010?
Your answer should be very brief. 0.76. What is the ratio of the Claims(annual growth as % of broad money) in Nicaragua in 2008 to that in 2010?
Make the answer very short. 2.34. What is the ratio of the Claims(annual growth as % of broad money) of St. Kitts and Nevis in 2008 to that in 2010?
Make the answer very short. 1.79. What is the ratio of the Claims(annual growth as % of broad money) in Eritrea in 2009 to that in 2010?
Keep it short and to the point. 0.14. What is the ratio of the Claims(annual growth as % of broad money) of Macao in 2009 to that in 2010?
Offer a terse response. 0.35. What is the difference between the highest and the second highest Claims(annual growth as % of broad money) in Eritrea?
Your response must be concise. 0.1. What is the difference between the highest and the second highest Claims(annual growth as % of broad money) in Macao?
Provide a short and direct response. 1.27. What is the difference between the highest and the second highest Claims(annual growth as % of broad money) of Nicaragua?
Provide a short and direct response. 5.41. What is the difference between the highest and the second highest Claims(annual growth as % of broad money) of St. Kitts and Nevis?
Provide a short and direct response. 4.05. What is the difference between the highest and the lowest Claims(annual growth as % of broad money) in Eritrea?
Give a very brief answer. 3.39. What is the difference between the highest and the lowest Claims(annual growth as % of broad money) in Macao?
Provide a succinct answer. 11.36. What is the difference between the highest and the lowest Claims(annual growth as % of broad money) of Nicaragua?
Give a very brief answer. 27.9. What is the difference between the highest and the lowest Claims(annual growth as % of broad money) of St. Kitts and Nevis?
Give a very brief answer. 13.65. 